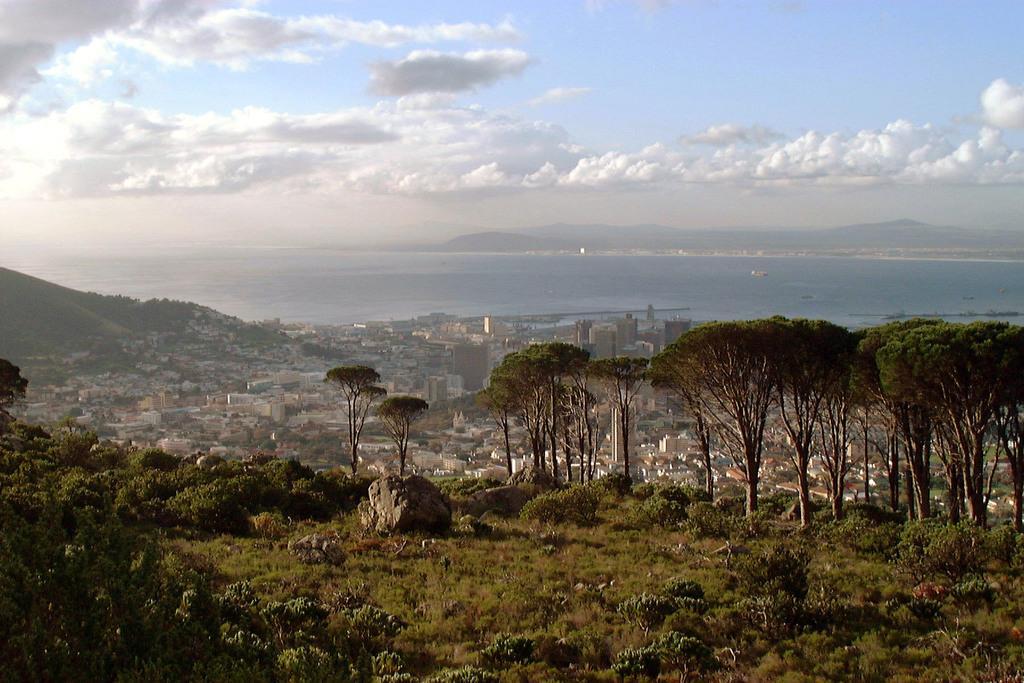Could you give a brief overview of what you see in this image? In this picture we can see few plants, trees and buildings, in the background we can find water, hills and clouds. 